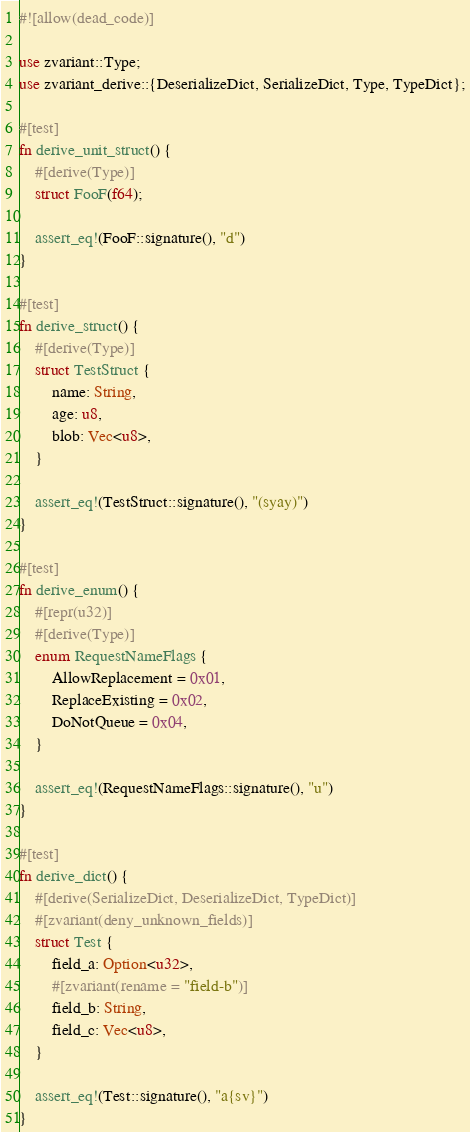<code> <loc_0><loc_0><loc_500><loc_500><_Rust_>#![allow(dead_code)]

use zvariant::Type;
use zvariant_derive::{DeserializeDict, SerializeDict, Type, TypeDict};

#[test]
fn derive_unit_struct() {
    #[derive(Type)]
    struct FooF(f64);

    assert_eq!(FooF::signature(), "d")
}

#[test]
fn derive_struct() {
    #[derive(Type)]
    struct TestStruct {
        name: String,
        age: u8,
        blob: Vec<u8>,
    }

    assert_eq!(TestStruct::signature(), "(syay)")
}

#[test]
fn derive_enum() {
    #[repr(u32)]
    #[derive(Type)]
    enum RequestNameFlags {
        AllowReplacement = 0x01,
        ReplaceExisting = 0x02,
        DoNotQueue = 0x04,
    }

    assert_eq!(RequestNameFlags::signature(), "u")
}

#[test]
fn derive_dict() {
    #[derive(SerializeDict, DeserializeDict, TypeDict)]
    #[zvariant(deny_unknown_fields)]
    struct Test {
        field_a: Option<u32>,
        #[zvariant(rename = "field-b")]
        field_b: String,
        field_c: Vec<u8>,
    }

    assert_eq!(Test::signature(), "a{sv}")
}
</code> 